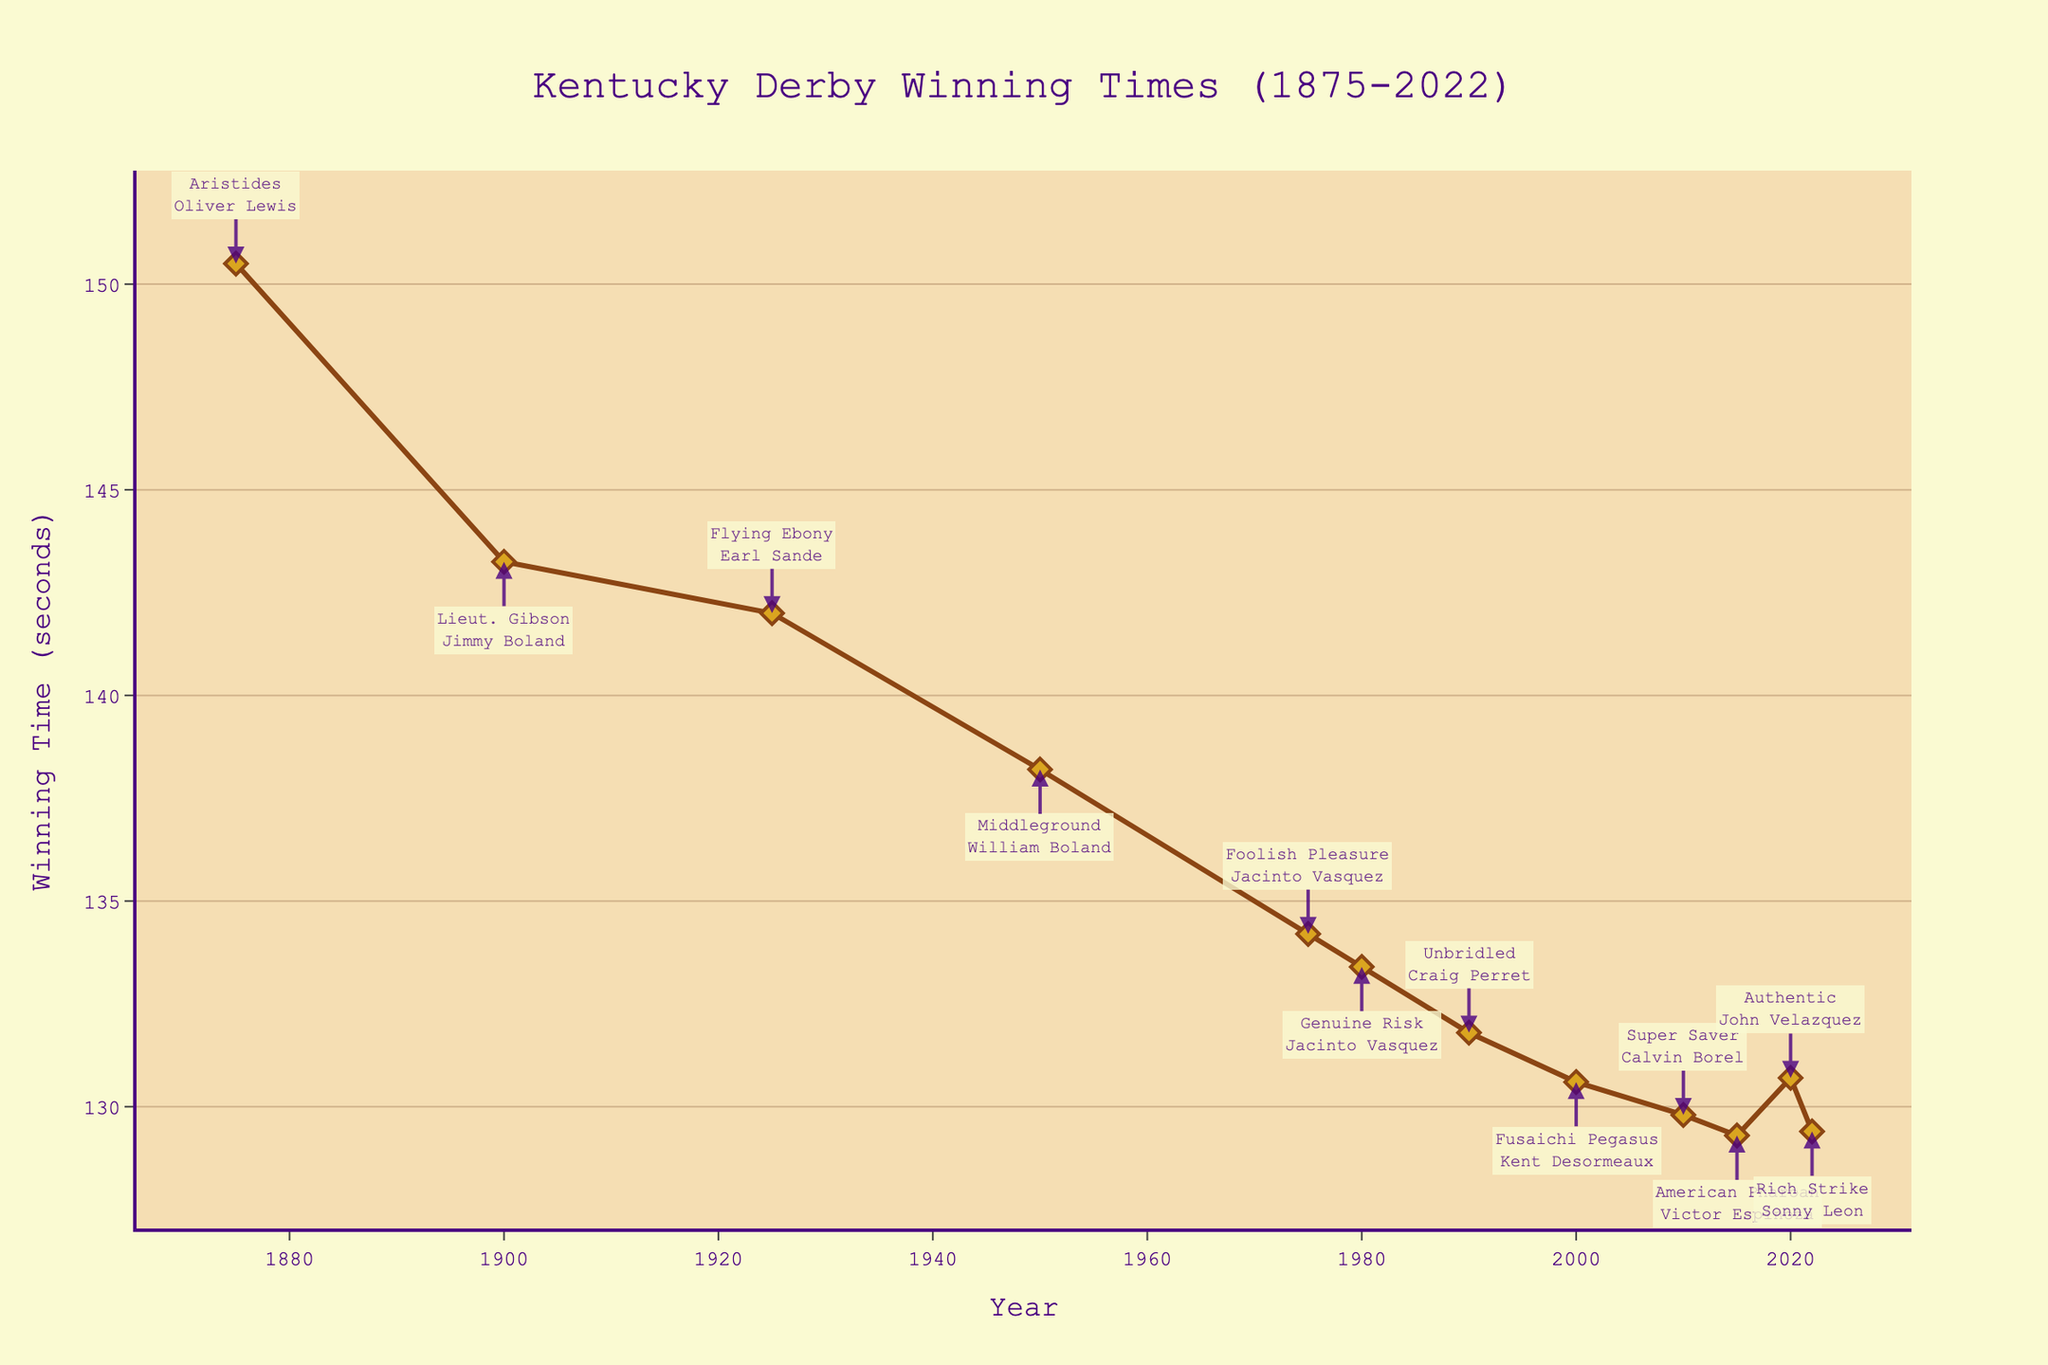What year had the fastest winning time in the Kentucky Derby? Look at the plot and find the point with the lowest y-value (Winning Time). The fastest winning time was achieved by American Pharoah in 2015 with a time of 129.3 seconds.
Answer: 2015 By how many seconds did the winning time improve from 1875 to 2010? Identify the winning times for 1875 (150.5 seconds) and 2010 (129.8 seconds) on the plot. Subtract the 2010 time from the 1875 time: 150.5 - 129.8 = 20.7 seconds.
Answer: 20.7 seconds Which jockey appears most often in the annotations on the plot? By examining the annotations, we see Jacinto Vasquez is mentioned twice, riding Foolish Pleasure in 1975 and Genuine Risk in 1980.
Answer: Jacinto Vasquez What is the approximate average winning time from 2000 to 2022? Identify the winning times from 2000 (130.6 seconds), 2010 (129.8 seconds), 2015 (129.3 seconds), 2020 (130.7 seconds), and 2022 (129.4 seconds). Compute the average: (130.6 + 129.8 + 129.3 + 130.7 + 129.4) / 5 = 129.96 seconds.
Answer: 129.96 seconds How much slower was the winning time in 2020 compared to 2015? Find the winning times for 2020 (130.7 seconds) and 2015 (129.3 seconds) on the plot. Subtract the 2015 time from the 2020 time: 130.7 - 129.3 = 1.4 seconds.
Answer: 1.4 seconds What trend can you observe in the winning times from 1900 to 2022? Observe the general direction and pattern of the line from 1900 to 2022. Overall, the winning times decrease, indicating a trend towards faster races over time.
Answer: Decreasing trend Who was the winning horse in 1950, and what was its winning time? Look at the annotation near the year 1950, which identifies Middleground as the winning horse with a time of 138.2 seconds.
Answer: Middleground, 138.2 seconds Which year between 2000 to 2022 had the second-fastest winning time? Identify the winning times between 2000 and 2022. The second-fastest winning time was 129.4 seconds in 2022, just behind 2015's 129.3 seconds.
Answer: 2022 From the plot, which year saw a significant drop in winning time compared to the previous year shown? Notice the significant drop from 1875 (150.5 seconds) to 1900 (143.25 seconds) on the plot. The next notable drop is from 1950 (138.2 seconds) to 1975 (134.2 seconds).
Answer: 1875 to 1900, 1950 to 1975 